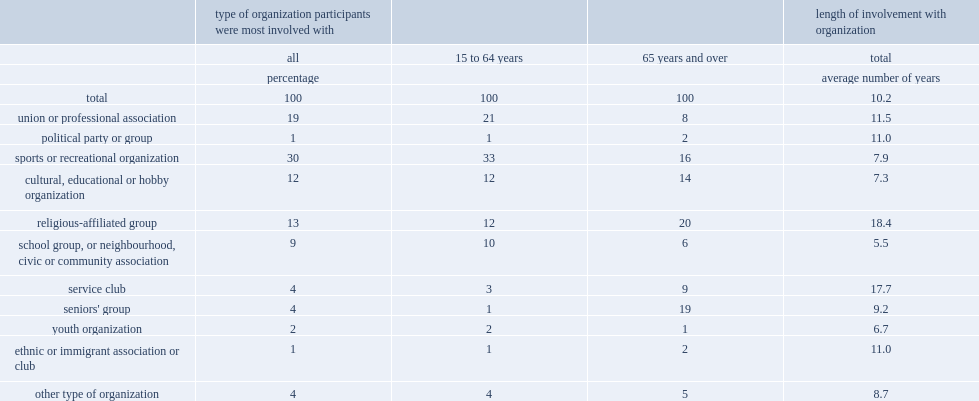What was the proportion of seniors aged 65 and over were mainly involved with religious-affiliated groups? 20.0. What was the proportion of seniors aged 65 and over were mainly involved with seniors' groups? 19.0. What was the proportion of people aged 64 and under were more likely to be mainly involved in sports and recreational organizations? 33.0. 